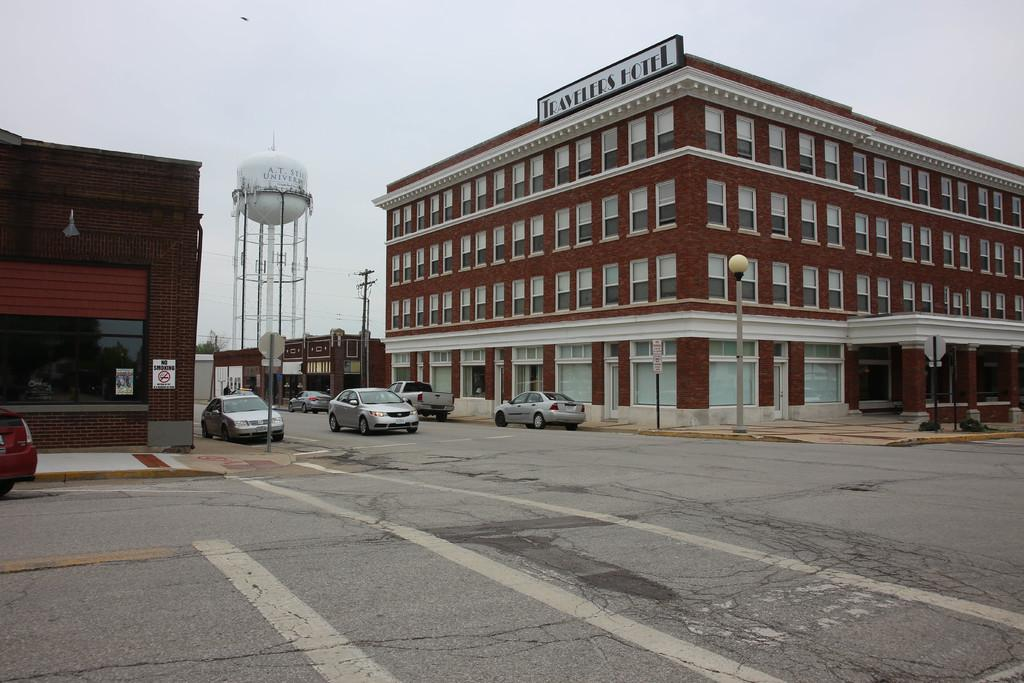What can be seen at the bottom of the image? There are vehicles on the road at the bottom of the image. What is visible in the background of the image? Buildings, windows, poles, electric poles, a sign board pole, trees, and the sky are visible in the background of the image. Can you describe the name board in the image? The name board is on the wall in the background of the image. How many rings are visible on the vehicles in the image? There is no mention of rings on the vehicles in the image. What color is the skateboard in the image? There is no skateboard present in the image. 